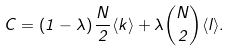<formula> <loc_0><loc_0><loc_500><loc_500>C = \left ( 1 - \lambda \right ) \frac { N } { 2 } \langle k \rangle + \lambda \binom { N } { 2 } \langle l \rangle .</formula> 